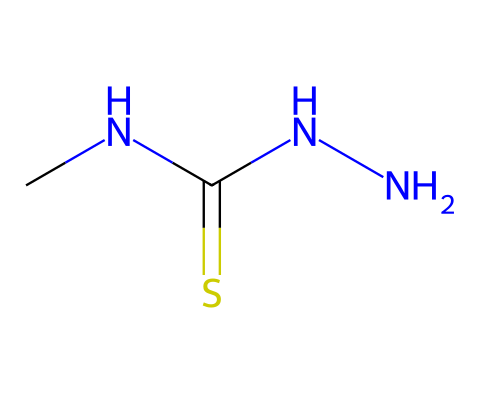What is the main functional group present in this compound? The compound has the structure indicated by the presence of a thioamide (C= S site), which is a defining feature of this specific functional group.
Answer: thioamide How many nitrogen atoms are in the given chemical structure? By analyzing the SMILES representation, we can identify that there are two nitrogen atoms directly represented by 'N' in the structure.
Answer: two What type of bonds connect nitrogen and carbon in this chemical? The nitrogen atoms are connected to carbon via single bonds; the 'N' is directly adjacent to 'C', indicating a single covalent bond.
Answer: single bonds Which element in this compound might contribute to its low solubility in water? The sulfur atom (S) is often associated with lower solubility in water due to its larger size and less polar nature compared to oxygen, which can hinder solvation.
Answer: sulfur What is the total number of atoms in this hydrazine derivative? Counting each unique atom from the SMILES representation shows there are 5 total atoms: 2 nitrogen, 2 carbon, and 1 sulfur.
Answer: five How many functional groups are present in this molecule? The molecule has one thioamide group, which is the only functional group apparent from the chemical structure provided.
Answer: one 